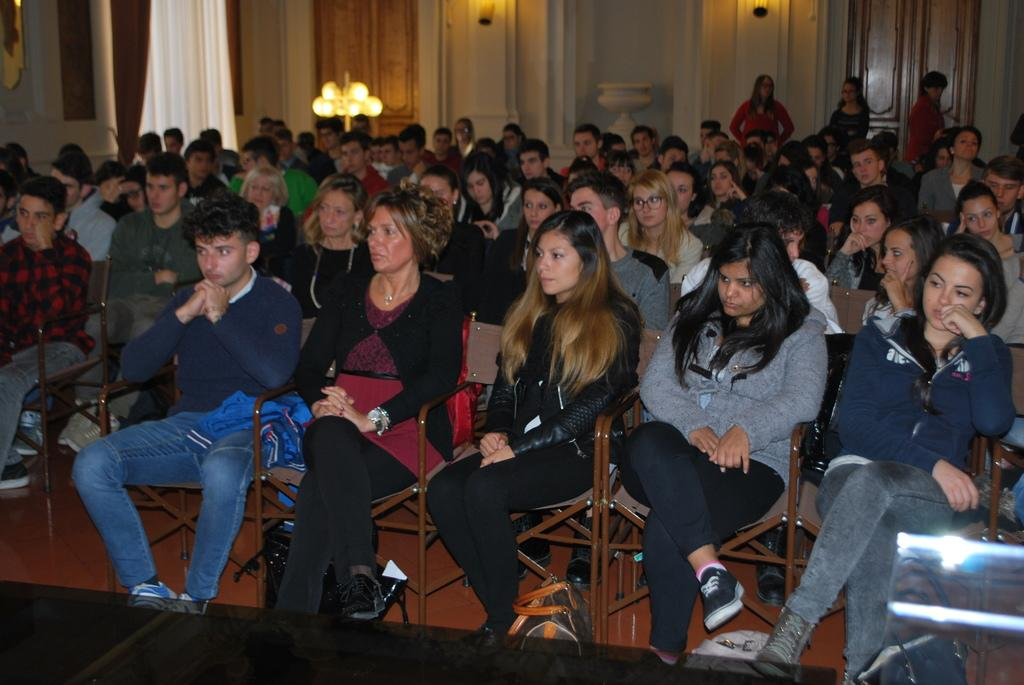What are the people in the image doing? The men and women in the image are sitting on chairs. What can be seen on the floor in the background of the image? There are bags on the floor in the background of the image. What type of window treatment is visible in the image? There are curtains on the windows in the background of the image. What type of architectural feature is visible in the background of the image? There are walls visible in the background of the image. What type of science experiment is being conducted on the stove in the image? There is no stove or science experiment present in the image. 